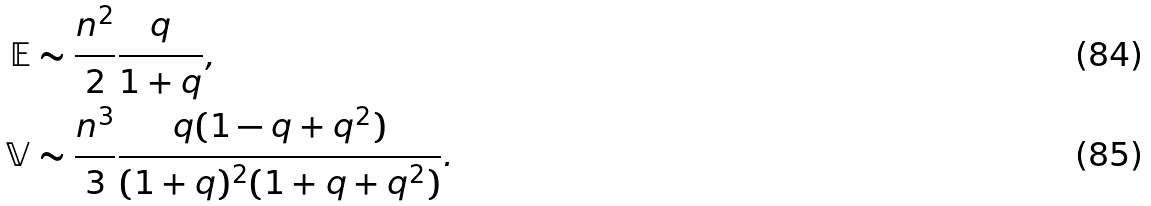Convert formula to latex. <formula><loc_0><loc_0><loc_500><loc_500>\mathbb { E } & \sim \frac { n ^ { 2 } } { 2 } \frac { q } { 1 + q } , \\ \mathbb { V } & \sim \frac { n ^ { 3 } } { 3 } \frac { q ( 1 - q + q ^ { 2 } ) } { ( 1 + q ) ^ { 2 } ( 1 + q + q ^ { 2 } ) } .</formula> 